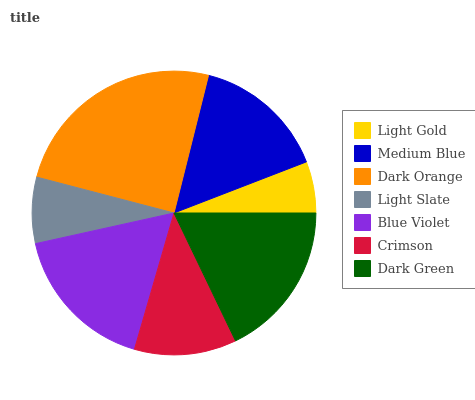Is Light Gold the minimum?
Answer yes or no. Yes. Is Dark Orange the maximum?
Answer yes or no. Yes. Is Medium Blue the minimum?
Answer yes or no. No. Is Medium Blue the maximum?
Answer yes or no. No. Is Medium Blue greater than Light Gold?
Answer yes or no. Yes. Is Light Gold less than Medium Blue?
Answer yes or no. Yes. Is Light Gold greater than Medium Blue?
Answer yes or no. No. Is Medium Blue less than Light Gold?
Answer yes or no. No. Is Medium Blue the high median?
Answer yes or no. Yes. Is Medium Blue the low median?
Answer yes or no. Yes. Is Dark Orange the high median?
Answer yes or no. No. Is Dark Green the low median?
Answer yes or no. No. 